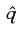Convert formula to latex. <formula><loc_0><loc_0><loc_500><loc_500>\hat { q }</formula> 